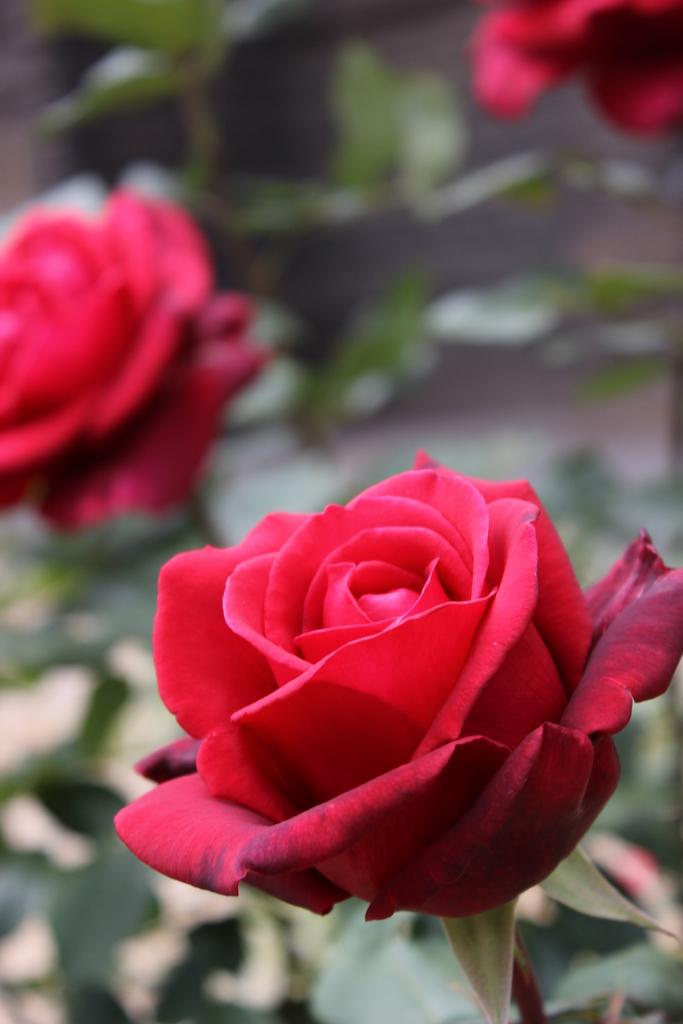What type of living organisms can be seen in the image? Plants can be seen in the image. Can you describe any specific flowers among the plants? Yes, there are red color roses in the image. What type of headwear is the plant wearing in the image? There is no headwear present in the image, as the subject is plants and flowers. What type of paint is being used to color the stick in the image? There is no stick or paint present in the image; it features plants and flowers. 